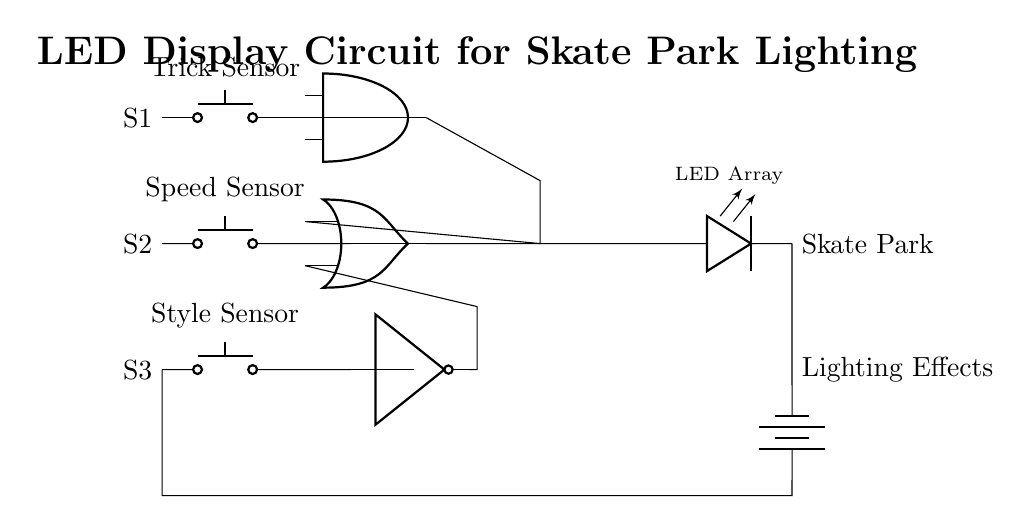What are the input components in this circuit? The input components are S1, S2, and S3, which are all push buttons responsible for triggering the logic gates.
Answer: S1, S2, S3 What type of logic gate connects the outputs of S1 and S2? The logic gate connecting S1 and S2 is an AND gate, which requires both inputs to be high for the output to be high.
Answer: AND What is the output component of the circuit? The output component is an LED array, which lights up based on the logic processed by the gates from the inputs.
Answer: LED Array What logic gate is processing the output from S3? The gate processing the output from S3 is a NOT gate, which inverts the input signal from S3.
Answer: NOT If S1 is pressed and S2 is not pressed, what is the state of the AND gate? The AND gate will output low since one of its inputs (from S2) is low, and for it to output high, both inputs must be high.
Answer: Low What is the role of the OR gate in this circuit? The OR gate combines the outputs of the AND gate and the NOT gate, outputting high if at least one of the inputs is high, which will activate the LED array.
Answer: Combining outputs What determines the activation of the LED array? The activation of the LED array is determined by the combined output from the OR gate, which depends on the states of S1, S2, and S3 processed through the gates.
Answer: Output from OR gate 